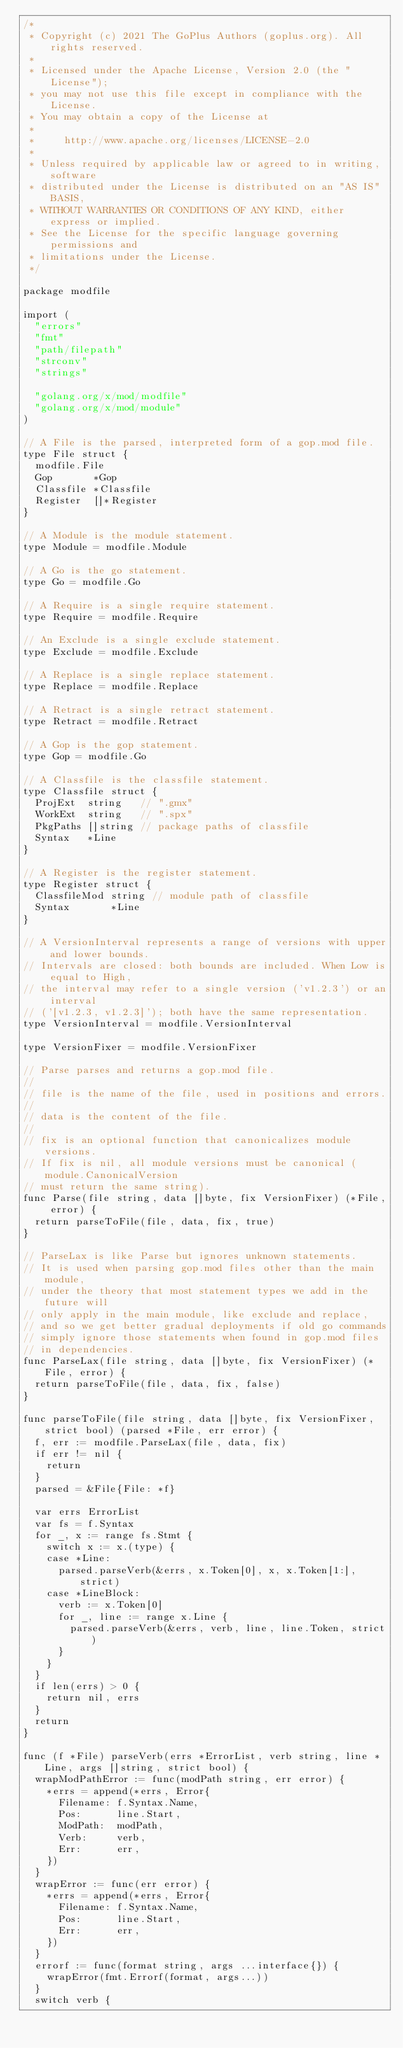Convert code to text. <code><loc_0><loc_0><loc_500><loc_500><_Go_>/*
 * Copyright (c) 2021 The GoPlus Authors (goplus.org). All rights reserved.
 *
 * Licensed under the Apache License, Version 2.0 (the "License");
 * you may not use this file except in compliance with the License.
 * You may obtain a copy of the License at
 *
 *     http://www.apache.org/licenses/LICENSE-2.0
 *
 * Unless required by applicable law or agreed to in writing, software
 * distributed under the License is distributed on an "AS IS" BASIS,
 * WITHOUT WARRANTIES OR CONDITIONS OF ANY KIND, either express or implied.
 * See the License for the specific language governing permissions and
 * limitations under the License.
 */

package modfile

import (
	"errors"
	"fmt"
	"path/filepath"
	"strconv"
	"strings"

	"golang.org/x/mod/modfile"
	"golang.org/x/mod/module"
)

// A File is the parsed, interpreted form of a gop.mod file.
type File struct {
	modfile.File
	Gop       *Gop
	Classfile *Classfile
	Register  []*Register
}

// A Module is the module statement.
type Module = modfile.Module

// A Go is the go statement.
type Go = modfile.Go

// A Require is a single require statement.
type Require = modfile.Require

// An Exclude is a single exclude statement.
type Exclude = modfile.Exclude

// A Replace is a single replace statement.
type Replace = modfile.Replace

// A Retract is a single retract statement.
type Retract = modfile.Retract

// A Gop is the gop statement.
type Gop = modfile.Go

// A Classfile is the classfile statement.
type Classfile struct {
	ProjExt  string   // ".gmx"
	WorkExt  string   // ".spx"
	PkgPaths []string // package paths of classfile
	Syntax   *Line
}

// A Register is the register statement.
type Register struct {
	ClassfileMod string // module path of classfile
	Syntax       *Line
}

// A VersionInterval represents a range of versions with upper and lower bounds.
// Intervals are closed: both bounds are included. When Low is equal to High,
// the interval may refer to a single version ('v1.2.3') or an interval
// ('[v1.2.3, v1.2.3]'); both have the same representation.
type VersionInterval = modfile.VersionInterval

type VersionFixer = modfile.VersionFixer

// Parse parses and returns a gop.mod file.
//
// file is the name of the file, used in positions and errors.
//
// data is the content of the file.
//
// fix is an optional function that canonicalizes module versions.
// If fix is nil, all module versions must be canonical (module.CanonicalVersion
// must return the same string).
func Parse(file string, data []byte, fix VersionFixer) (*File, error) {
	return parseToFile(file, data, fix, true)
}

// ParseLax is like Parse but ignores unknown statements.
// It is used when parsing gop.mod files other than the main module,
// under the theory that most statement types we add in the future will
// only apply in the main module, like exclude and replace,
// and so we get better gradual deployments if old go commands
// simply ignore those statements when found in gop.mod files
// in dependencies.
func ParseLax(file string, data []byte, fix VersionFixer) (*File, error) {
	return parseToFile(file, data, fix, false)
}

func parseToFile(file string, data []byte, fix VersionFixer, strict bool) (parsed *File, err error) {
	f, err := modfile.ParseLax(file, data, fix)
	if err != nil {
		return
	}
	parsed = &File{File: *f}

	var errs ErrorList
	var fs = f.Syntax
	for _, x := range fs.Stmt {
		switch x := x.(type) {
		case *Line:
			parsed.parseVerb(&errs, x.Token[0], x, x.Token[1:], strict)
		case *LineBlock:
			verb := x.Token[0]
			for _, line := range x.Line {
				parsed.parseVerb(&errs, verb, line, line.Token, strict)
			}
		}
	}
	if len(errs) > 0 {
		return nil, errs
	}
	return
}

func (f *File) parseVerb(errs *ErrorList, verb string, line *Line, args []string, strict bool) {
	wrapModPathError := func(modPath string, err error) {
		*errs = append(*errs, Error{
			Filename: f.Syntax.Name,
			Pos:      line.Start,
			ModPath:  modPath,
			Verb:     verb,
			Err:      err,
		})
	}
	wrapError := func(err error) {
		*errs = append(*errs, Error{
			Filename: f.Syntax.Name,
			Pos:      line.Start,
			Err:      err,
		})
	}
	errorf := func(format string, args ...interface{}) {
		wrapError(fmt.Errorf(format, args...))
	}
	switch verb {</code> 